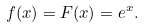Convert formula to latex. <formula><loc_0><loc_0><loc_500><loc_500>f ( x ) = F ( x ) = e ^ { x } . \\</formula> 